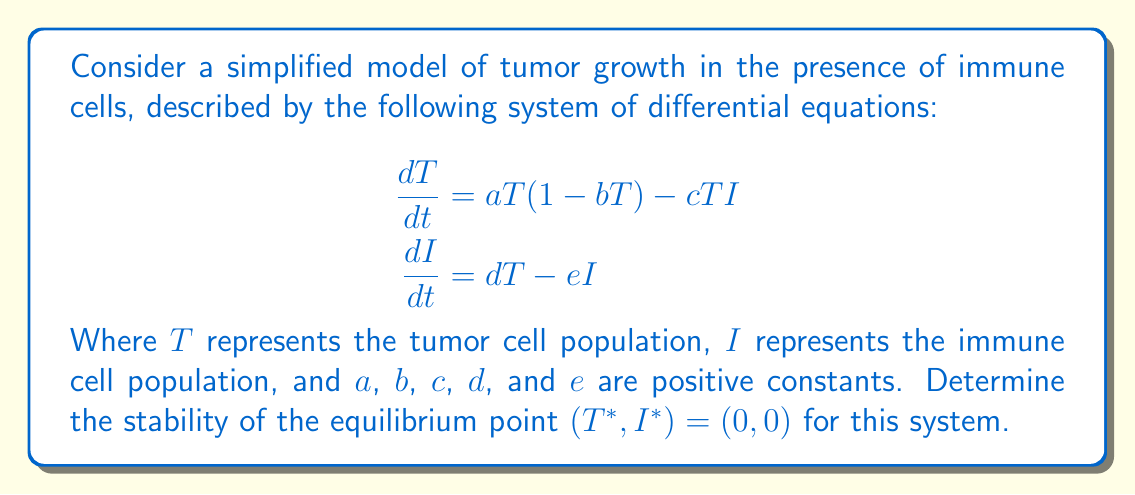Can you answer this question? To determine the stability of the equilibrium point $(T^*, I^*) = (0, 0)$, we need to follow these steps:

1) First, we need to calculate the Jacobian matrix of the system at the equilibrium point.

2) The Jacobian matrix is given by:

   $$J = \begin{bmatrix}
   \frac{\partial f_1}{\partial T} & \frac{\partial f_1}{\partial I} \\
   \frac{\partial f_2}{\partial T} & \frac{\partial f_2}{\partial I}
   \end{bmatrix}$$

   Where $f_1 = aT(1-bT) - cTI$ and $f_2 = dT - eI$

3) Calculating the partial derivatives:

   $$\begin{aligned}
   \frac{\partial f_1}{\partial T} &= a(1-2bT) - cI \\
   \frac{\partial f_1}{\partial I} &= -cT \\
   \frac{\partial f_2}{\partial T} &= d \\
   \frac{\partial f_2}{\partial I} &= -e
   \end{aligned}$$

4) Evaluating the Jacobian at the equilibrium point $(0, 0)$:

   $$J_{(0,0)} = \begin{bmatrix}
   a & 0 \\
   d & -e
   \end{bmatrix}$$

5) To determine stability, we need to find the eigenvalues of this matrix. The characteristic equation is:

   $$\det(J_{(0,0)} - \lambda I) = \begin{vmatrix}
   a - \lambda & 0 \\
   d & -e - \lambda
   \end{vmatrix} = 0$$

6) Expanding this determinant:

   $$(a - \lambda)(-e - \lambda) = 0$$

7) Solving for $\lambda$:

   $$\lambda_1 = a, \quad \lambda_2 = -e$$

8) For stability, we need both eigenvalues to have negative real parts. Here, $\lambda_1 = a > 0$ (since $a$ is a positive constant), and $\lambda_2 = -e < 0$.

Therefore, since one eigenvalue is positive and one is negative, the equilibrium point $(0, 0)$ is an unstable saddle point.
Answer: The equilibrium point $(T^*, I^*) = (0, 0)$ is unstable. Specifically, it is an unstable saddle point. 